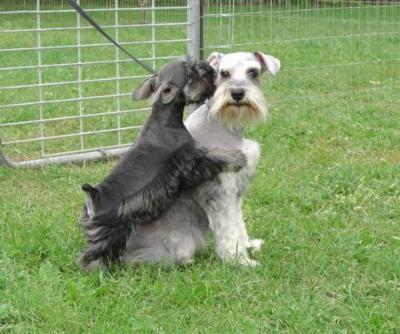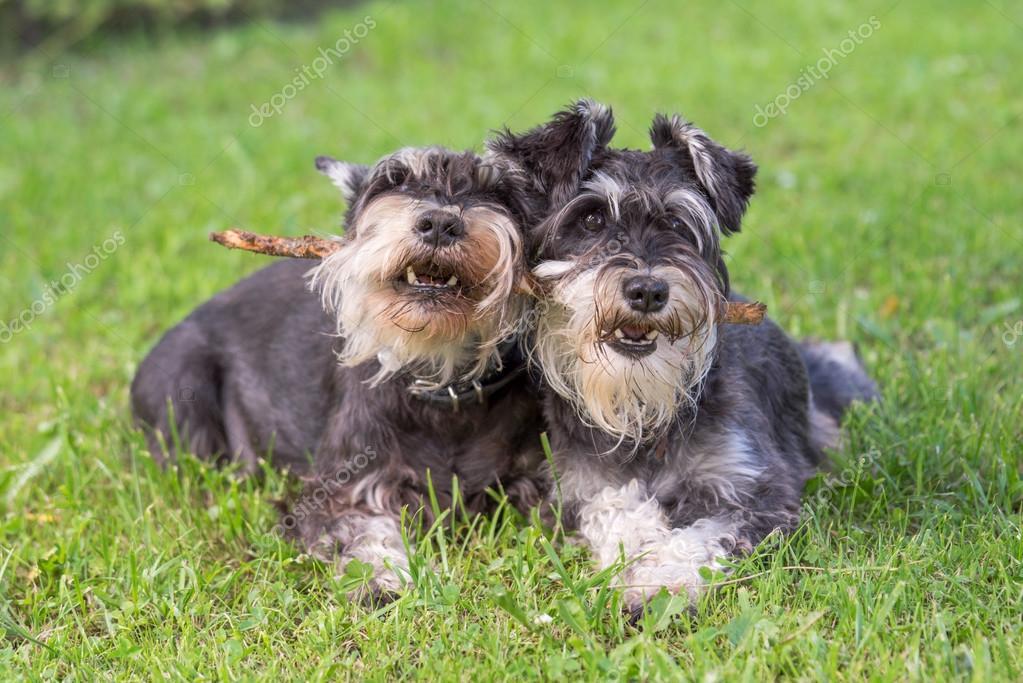The first image is the image on the left, the second image is the image on the right. Considering the images on both sides, is "The left image shows a grayer dog to the left of a whiter dog, and the right image shows at least one schnauzer with something held in its mouth." valid? Answer yes or no. Yes. The first image is the image on the left, the second image is the image on the right. Examine the images to the left and right. Is the description "There is exactly one dog holding a toy in its mouth." accurate? Answer yes or no. No. 